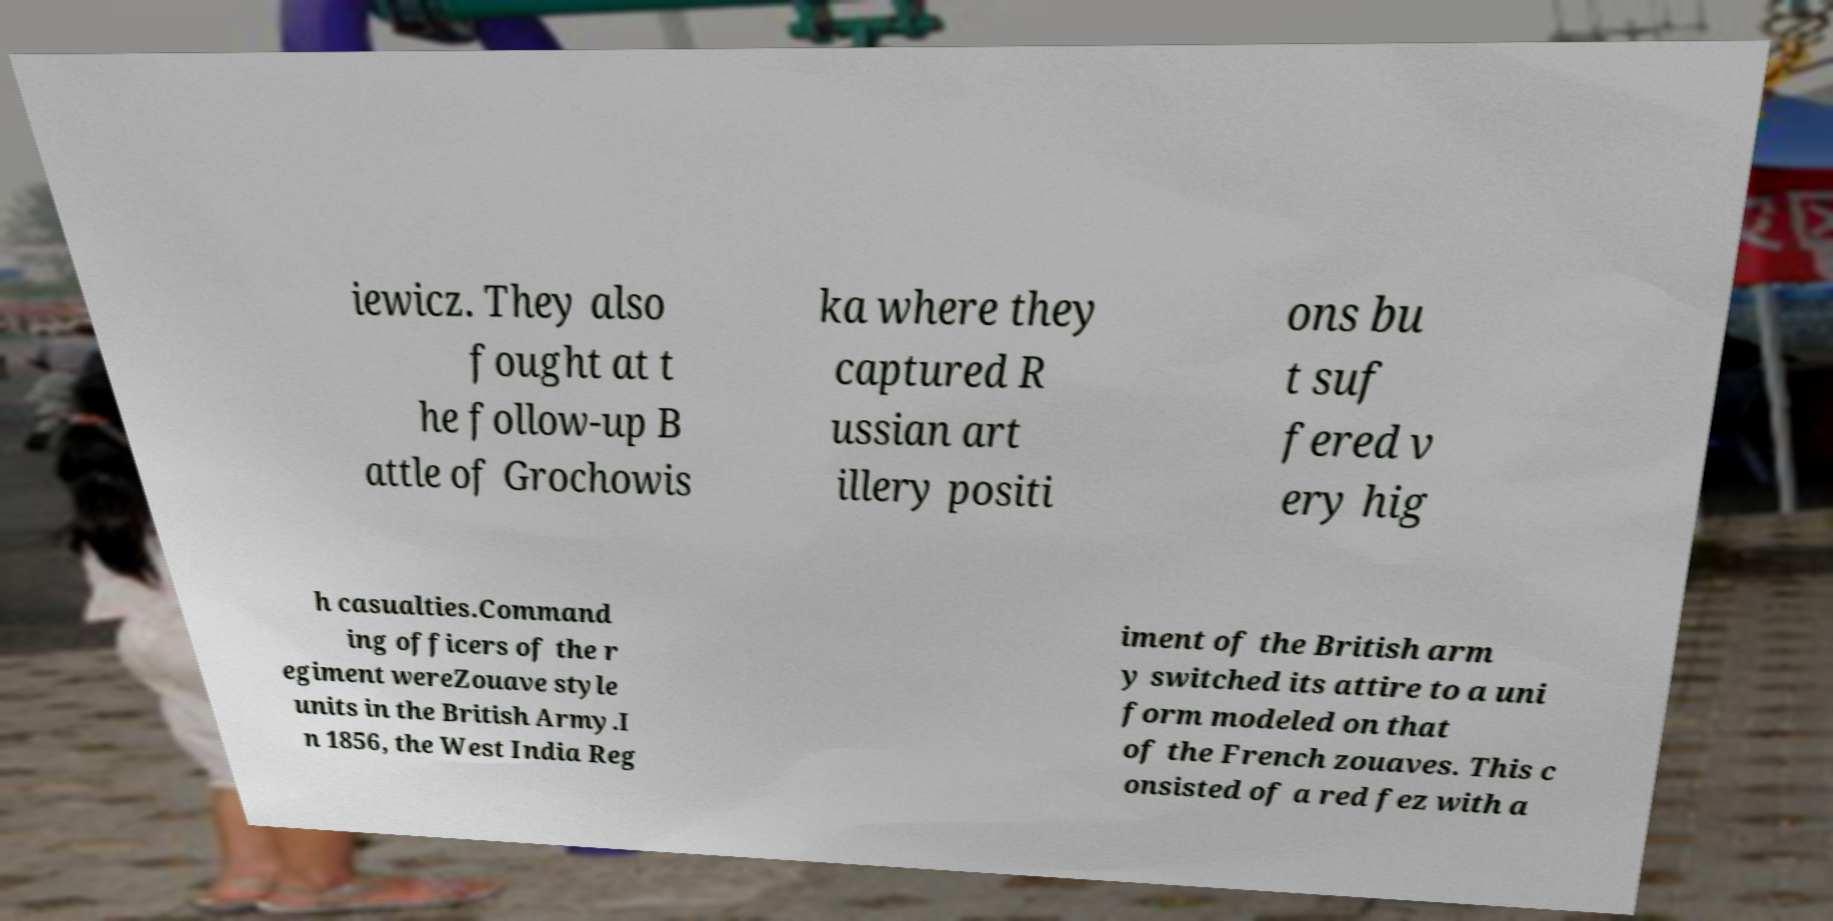Please identify and transcribe the text found in this image. iewicz. They also fought at t he follow-up B attle of Grochowis ka where they captured R ussian art illery positi ons bu t suf fered v ery hig h casualties.Command ing officers of the r egiment wereZouave style units in the British Army.I n 1856, the West India Reg iment of the British arm y switched its attire to a uni form modeled on that of the French zouaves. This c onsisted of a red fez with a 